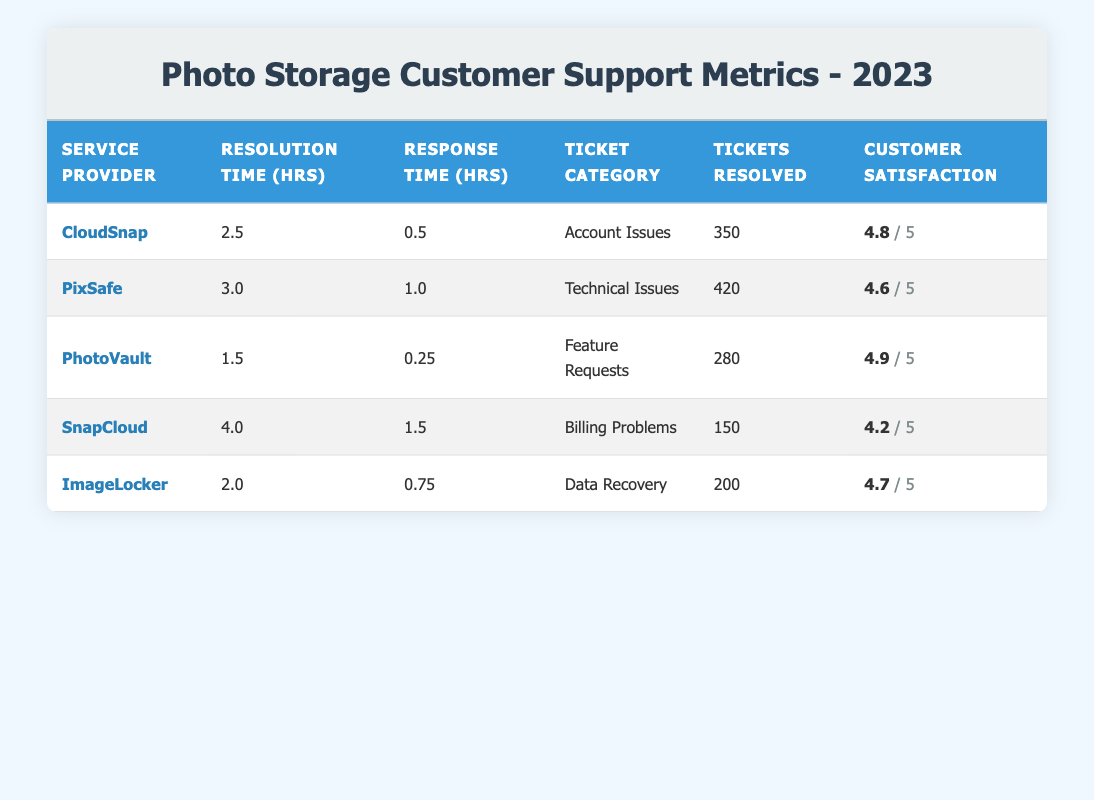What is the maximum resolution time among the service providers? To find the maximum resolution time, we need to look at the "Resolution Time (hrs)" column. The values are 2.5, 3.0, 1.5, 4.0, and 2.0. The highest value is 4.0 hours, which corresponds to SnapCloud.
Answer: 4.0 hours Which service provider had the highest customer satisfaction rating? In the "Customer Satisfaction" column, we see ratings of 4.8, 4.6, 4.9, 4.2, and 4.7. The highest rating is 4.9, which belongs to PhotoVault.
Answer: PhotoVault How many total tickets were resolved across all service providers? To find the total tickets resolved, we add up the "Tickets Resolved" values: 350 + 420 + 280 + 150 + 200 = 1400.
Answer: 1400 What is the average response time across all service providers? First, we collect all the response times: 0.5, 1.0, 0.25, 1.5, and 0.75. We sum these values: 0.5 + 1.0 + 0.25 + 1.5 + 0.75 = 4.0 hours. There are 5 service providers, so we divide the total by 5: 4.0 / 5 = 0.8 hours.
Answer: 0.8 hours Did ImageLocker have a higher customer satisfaction than SnapCloud? ImageLocker has a satisfaction score of 4.7, while SnapCloud has a score of 4.2. Since 4.7 is greater than 4.2, the statement is true.
Answer: Yes Which ticket category had the shortest resolution time and what is that time? Looking at the "Resolution Time" values, we compare them: 2.5, 3.0, 1.5, 4.0, and 2.0. The shortest resolution time is 1.5 hours, which falls under "Feature Requests" for PhotoVault.
Answer: 1.5 hours How many more tickets were resolved by PixSafe compared to SnapCloud? PixSafe resolved 420 tickets while SnapCloud resolved 150. We subtract SnapCloud's resolved tickets from PixSafe's: 420 - 150 = 270.
Answer: 270 tickets Is the customer satisfaction score for PhotoVault greater than the average customer satisfaction across all providers? The customer satisfaction scores are 4.8, 4.6, 4.9, 4.2, and 4.7. The average is (4.8 + 4.6 + 4.9 + 4.2 + 4.7) / 5 = 4.64. Comparing this with PhotoVault's score of 4.9, it is indeed higher.
Answer: Yes What is the total resolution time for CloudSnap and ImageLocker combined? CloudSnap has a resolution time of 2.5 hours, and ImageLocker has a resolution time of 2.0 hours. We sum these two times: 2.5 + 2.0 = 4.5 hours.
Answer: 4.5 hours 